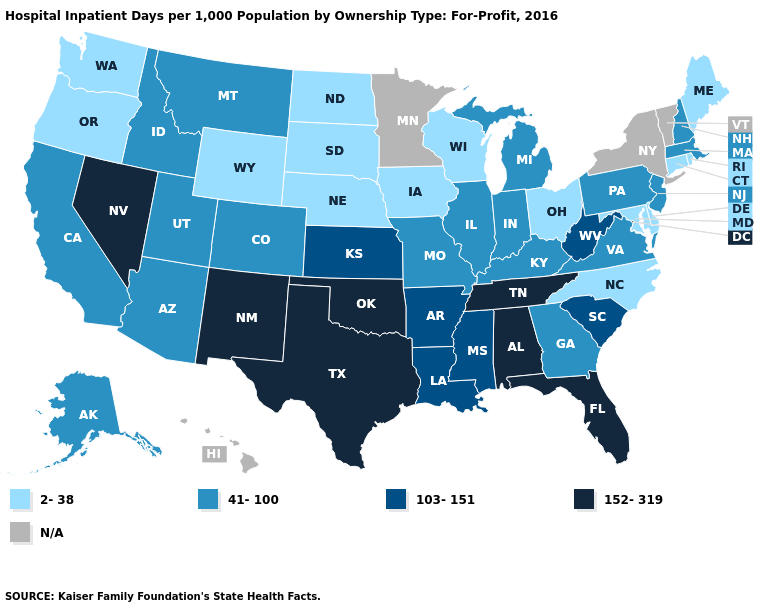What is the lowest value in states that border Texas?
Be succinct. 103-151. Name the states that have a value in the range 41-100?
Answer briefly. Alaska, Arizona, California, Colorado, Georgia, Idaho, Illinois, Indiana, Kentucky, Massachusetts, Michigan, Missouri, Montana, New Hampshire, New Jersey, Pennsylvania, Utah, Virginia. What is the highest value in states that border Florida?
Concise answer only. 152-319. What is the value of Rhode Island?
Write a very short answer. 2-38. Which states hav the highest value in the MidWest?
Write a very short answer. Kansas. Name the states that have a value in the range 2-38?
Write a very short answer. Connecticut, Delaware, Iowa, Maine, Maryland, Nebraska, North Carolina, North Dakota, Ohio, Oregon, Rhode Island, South Dakota, Washington, Wisconsin, Wyoming. Which states have the lowest value in the USA?
Give a very brief answer. Connecticut, Delaware, Iowa, Maine, Maryland, Nebraska, North Carolina, North Dakota, Ohio, Oregon, Rhode Island, South Dakota, Washington, Wisconsin, Wyoming. Among the states that border New Mexico , which have the highest value?
Concise answer only. Oklahoma, Texas. Name the states that have a value in the range 103-151?
Concise answer only. Arkansas, Kansas, Louisiana, Mississippi, South Carolina, West Virginia. What is the lowest value in the MidWest?
Keep it brief. 2-38. How many symbols are there in the legend?
Be succinct. 5. What is the value of Kansas?
Quick response, please. 103-151. Which states have the highest value in the USA?
Short answer required. Alabama, Florida, Nevada, New Mexico, Oklahoma, Tennessee, Texas. What is the value of Alaska?
Quick response, please. 41-100. Which states hav the highest value in the South?
Give a very brief answer. Alabama, Florida, Oklahoma, Tennessee, Texas. 